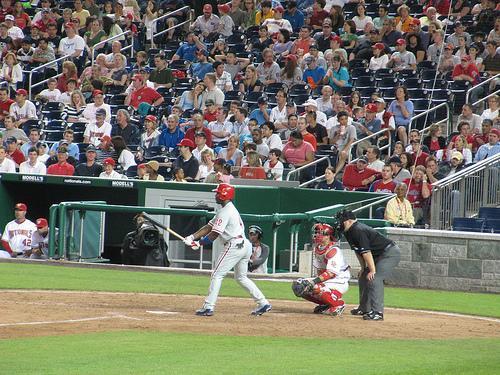How many people behind the batter?
Give a very brief answer. 2. How many umpires are pictured?
Give a very brief answer. 1. How many people are on the field?
Give a very brief answer. 3. 